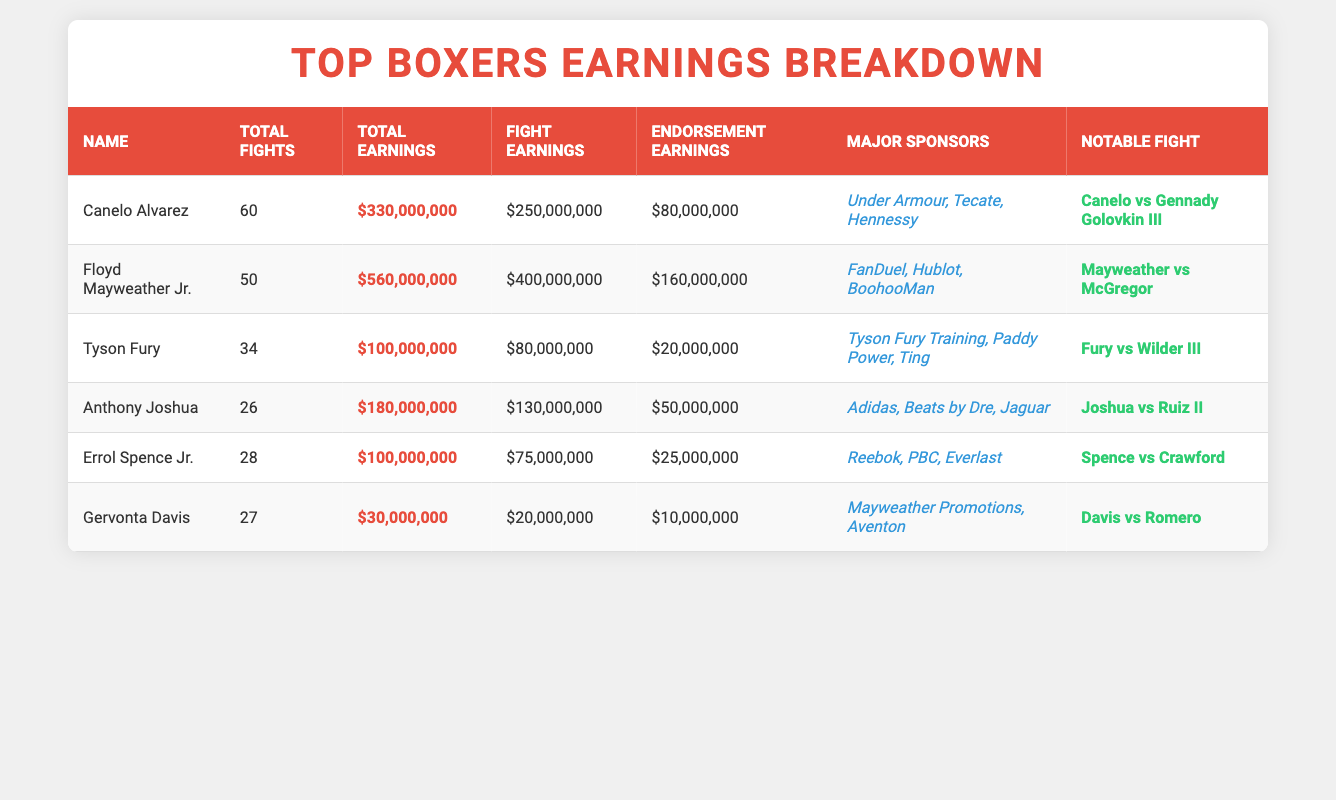What are the total earnings for Floyd Mayweather Jr.? The table lists Floyd Mayweather Jr.'s total earnings as $560,000,000.
Answer: $560,000,000 Which boxer has the highest fight earnings? By comparing the fight earnings from the table, Floyd Mayweather Jr. at $400,000,000 has the highest fight earnings.
Answer: Floyd Mayweather Jr What is the sum of total earnings for Canelo Alvarez and Anthony Joshua? Canelo Alvarez earns $330,000,000, and Anthony Joshua earns $180,000,000. So the sum is $330,000,000 + $180,000,000 = $510,000,000.
Answer: $510,000,000 Do all boxers have endorsement earnings over $10 million? Reviewing the endorsement earnings in the table, Gervonta Davis has $10,000,000, which means not all boxers exceed this amount.
Answer: No What is the average number of total fights for the listed boxers? There are 6 boxers with a total of 60, 50, 34, 26, 28, and 27 fights respectively. The total fights sum up to 225 (60 + 50 + 34 + 26 + 28 + 27), and dividing by 6 gives us an average of 37.5 fights.
Answer: 37.5 Which boxer has the least total earnings? By reviewing the total earnings, Gervonta Davis's total earnings of $30,000,000 is the lowest among all boxers in the table.
Answer: Gervonta Davis What is the difference in fight earnings between Tyson Fury and Anthony Joshua? Tyson Fury has fight earnings of $80,000,000, while Anthony Joshua has $130,000,000. The difference is $130,000,000 - $80,000,000 = $50,000,000.
Answer: $50,000,000 Is Canelo Alvarez's endorsement earnings greater than Errol Spence Jr.'s fight earnings? Canelo Alvarez's endorsement earnings of $80,000,000 are compared to Errol Spence Jr.'s fight earnings of $75,000,000. Since $80,000,000 is greater than $75,000,000, the answer is yes.
Answer: Yes What percentage of total earnings does Tyson Fury attribute to endorsements? Tyson Fury's total earnings are $100,000,000, and his endorsement earnings are $20,000,000. The percentage from endorsements is (20,000,000 / 100,000,000) * 100 = 20%.
Answer: 20% If you combine the fight earnings of Canelo Alvarez and Gervonta Davis, how much would that be? Canelo Alvarez has fight earnings of $250,000,000, and Gervonta Davis has $20,000,000. The combined total is $250,000,000 + $20,000,000 = $270,000,000.
Answer: $270,000,000 